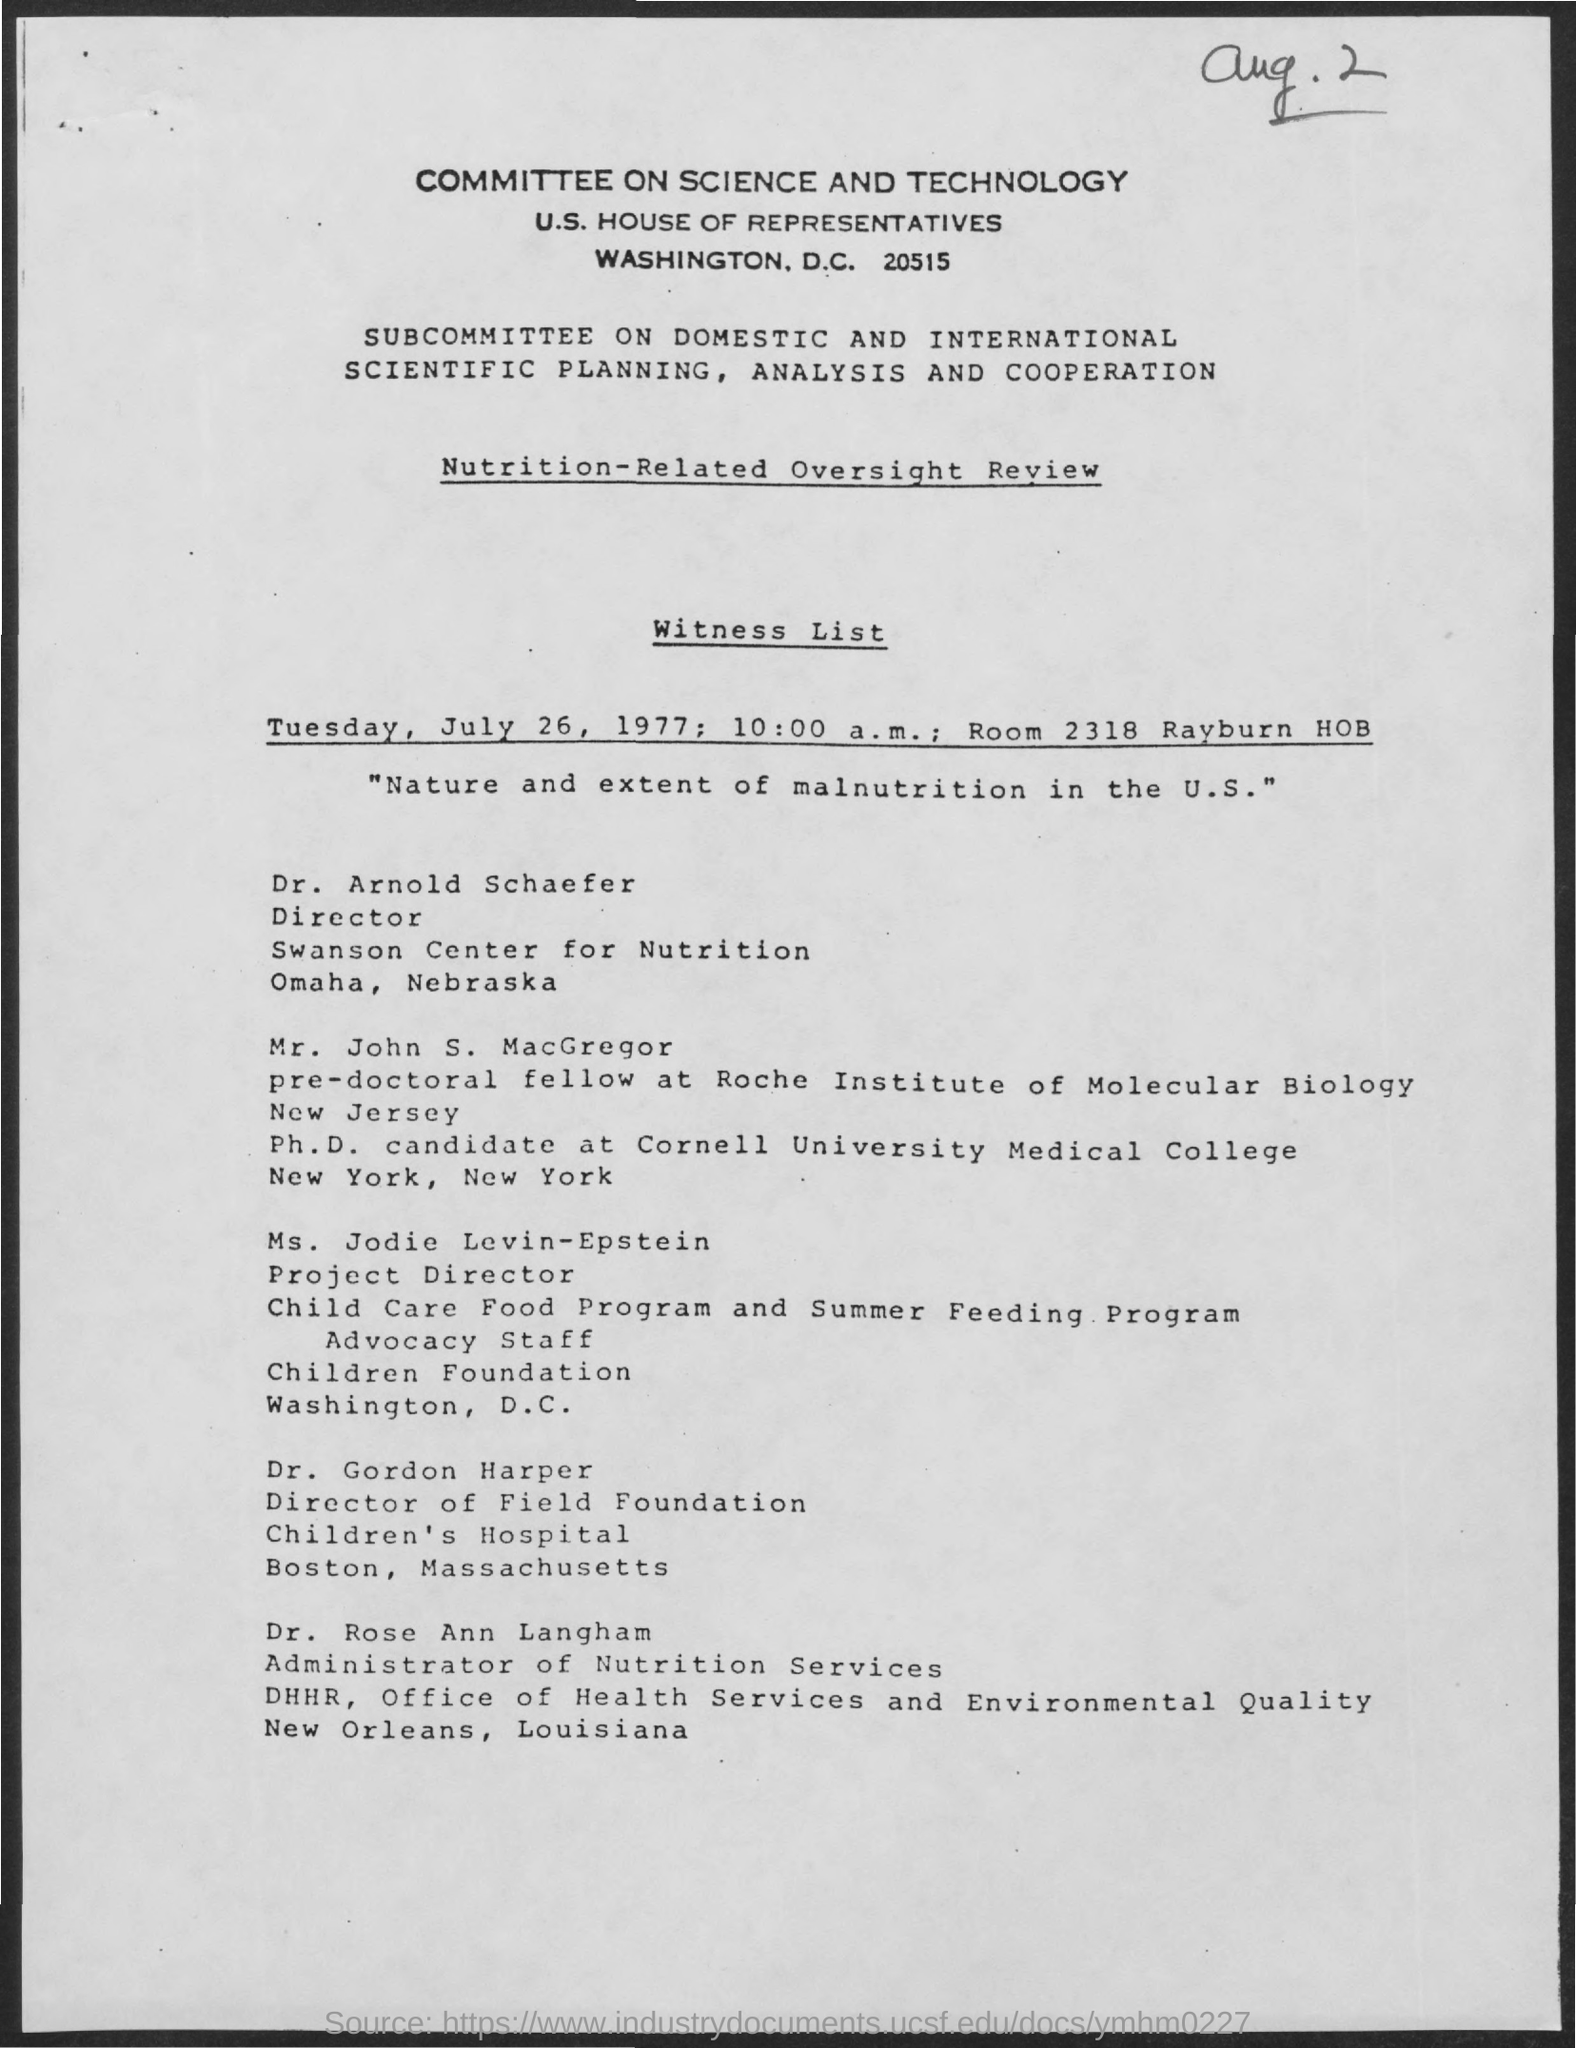Give some essential details in this illustration. The room number is 2318. The document mentions the time as 10:00 a.m. The title of the document is "Committee on Science and Technology. The document indicates that the date is Tuesday, July 26, 1977. 